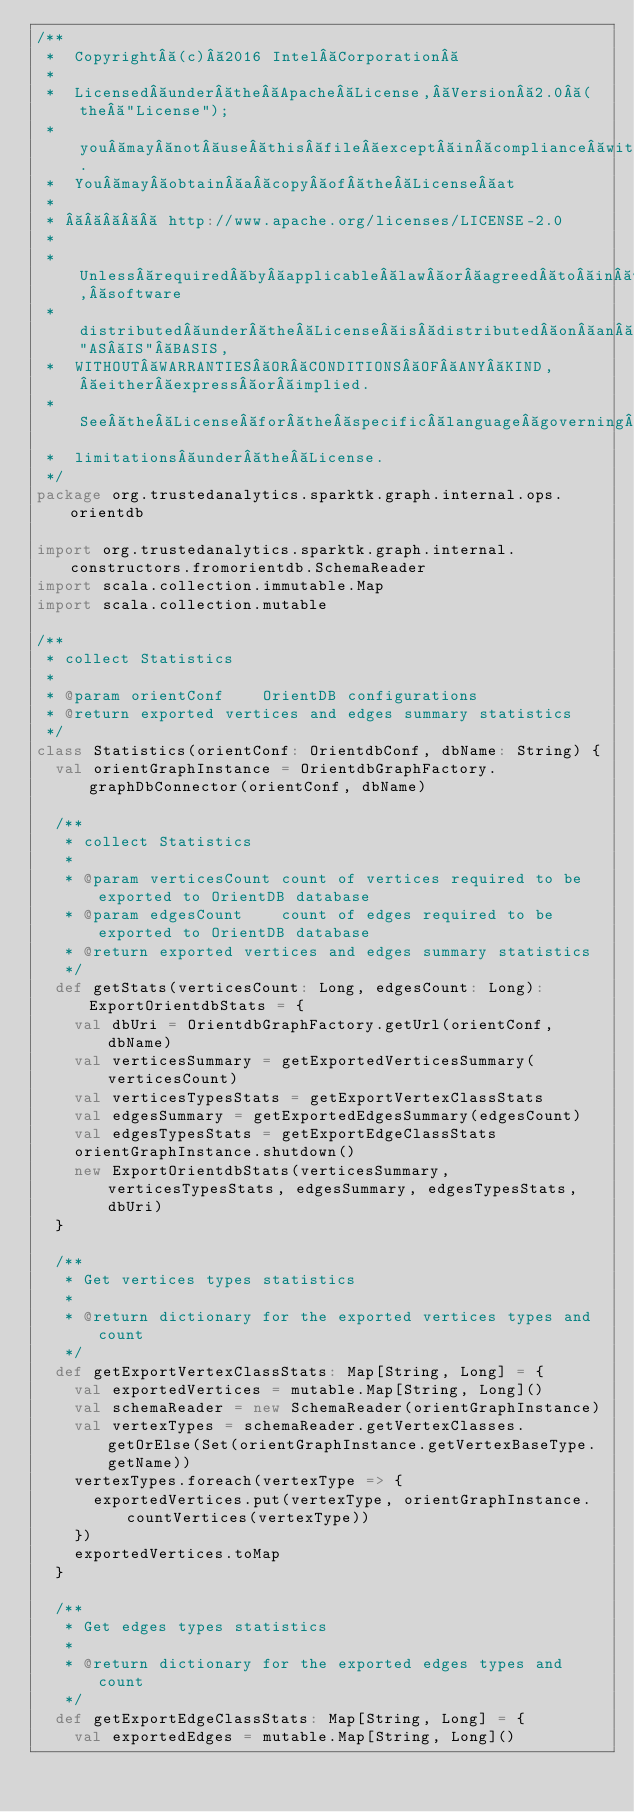Convert code to text. <code><loc_0><loc_0><loc_500><loc_500><_Scala_>/**
 *  Copyright (c) 2016 Intel Corporation 
 *
 *  Licensed under the Apache License, Version 2.0 (the "License");
 *  you may not use this file except in compliance with the License.
 *  You may obtain a copy of the License at
 *
 *       http://www.apache.org/licenses/LICENSE-2.0
 *
 *  Unless required by applicable law or agreed to in writing, software
 *  distributed under the License is distributed on an "AS IS" BASIS,
 *  WITHOUT WARRANTIES OR CONDITIONS OF ANY KIND, either express or implied.
 *  See the License for the specific language governing permissions and
 *  limitations under the License.
 */
package org.trustedanalytics.sparktk.graph.internal.ops.orientdb

import org.trustedanalytics.sparktk.graph.internal.constructors.fromorientdb.SchemaReader
import scala.collection.immutable.Map
import scala.collection.mutable

/**
 * collect Statistics
 *
 * @param orientConf    OrientDB configurations
 * @return exported vertices and edges summary statistics
 */
class Statistics(orientConf: OrientdbConf, dbName: String) {
  val orientGraphInstance = OrientdbGraphFactory.graphDbConnector(orientConf, dbName)

  /**
   * collect Statistics
   *
   * @param verticesCount count of vertices required to be exported to OrientDB database
   * @param edgesCount    count of edges required to be exported to OrientDB database
   * @return exported vertices and edges summary statistics
   */
  def getStats(verticesCount: Long, edgesCount: Long): ExportOrientdbStats = {
    val dbUri = OrientdbGraphFactory.getUrl(orientConf, dbName)
    val verticesSummary = getExportedVerticesSummary(verticesCount)
    val verticesTypesStats = getExportVertexClassStats
    val edgesSummary = getExportedEdgesSummary(edgesCount)
    val edgesTypesStats = getExportEdgeClassStats
    orientGraphInstance.shutdown()
    new ExportOrientdbStats(verticesSummary, verticesTypesStats, edgesSummary, edgesTypesStats, dbUri)
  }

  /**
   * Get vertices types statistics
   *
   * @return dictionary for the exported vertices types and count
   */
  def getExportVertexClassStats: Map[String, Long] = {
    val exportedVertices = mutable.Map[String, Long]()
    val schemaReader = new SchemaReader(orientGraphInstance)
    val vertexTypes = schemaReader.getVertexClasses.getOrElse(Set(orientGraphInstance.getVertexBaseType.getName))
    vertexTypes.foreach(vertexType => {
      exportedVertices.put(vertexType, orientGraphInstance.countVertices(vertexType))
    })
    exportedVertices.toMap
  }

  /**
   * Get edges types statistics
   *
   * @return dictionary for the exported edges types and count
   */
  def getExportEdgeClassStats: Map[String, Long] = {
    val exportedEdges = mutable.Map[String, Long]()</code> 